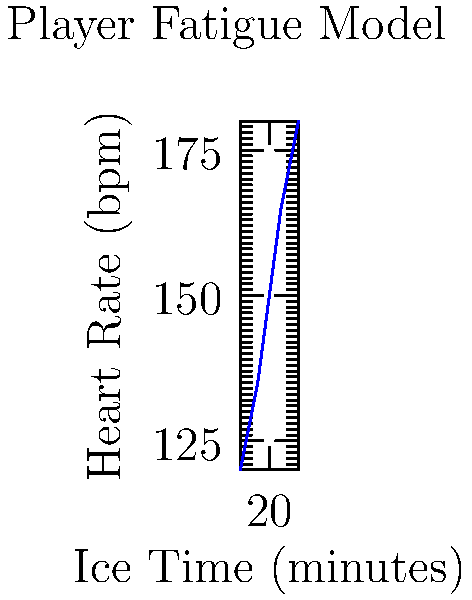Based on the graph showing the relationship between ice time and heart rate for a hockey player, what would be the estimated heart rate for a player who has been on the ice for 23 minutes? To estimate the heart rate for a player who has been on the ice for 23 minutes, we need to follow these steps:

1. Observe that the relationship between ice time and heart rate appears to be linear.

2. Identify two known points on the graph:
   - At 20 minutes, the heart rate is approximately 150 bpm
   - At 25 minutes, the heart rate is approximately 180 bpm

3. Calculate the slope of the line:
   $\text{Slope} = \frac{\text{Change in Heart Rate}}{\text{Change in Ice Time}} = \frac{180 - 150}{25 - 20} = \frac{30}{5} = 6$ bpm/minute

4. Use the point-slope form of a line equation:
   $y - y_1 = m(x - x_1)$, where $m$ is the slope, and $(x_1, y_1)$ is a known point

5. Plug in the values, using (20, 150) as our known point:
   $y - 150 = 6(x - 20)$

6. Solve for the heart rate (y) when ice time (x) is 23 minutes:
   $y - 150 = 6(23 - 20)$
   $y - 150 = 6(3) = 18$
   $y = 150 + 18 = 168$

Therefore, the estimated heart rate for a player who has been on the ice for 23 minutes is 168 bpm.
Answer: 168 bpm 